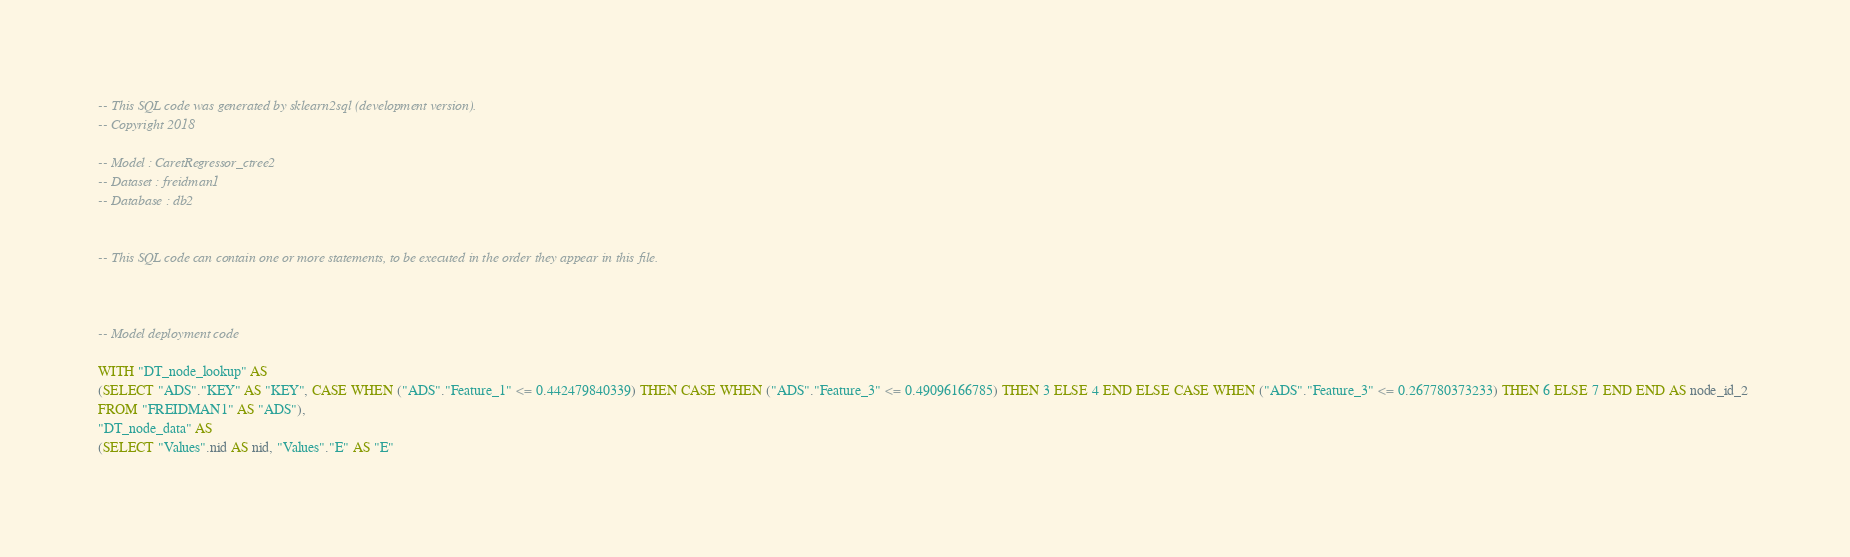Convert code to text. <code><loc_0><loc_0><loc_500><loc_500><_SQL_>-- This SQL code was generated by sklearn2sql (development version).
-- Copyright 2018

-- Model : CaretRegressor_ctree2
-- Dataset : freidman1
-- Database : db2


-- This SQL code can contain one or more statements, to be executed in the order they appear in this file.



-- Model deployment code

WITH "DT_node_lookup" AS 
(SELECT "ADS"."KEY" AS "KEY", CASE WHEN ("ADS"."Feature_1" <= 0.442479840339) THEN CASE WHEN ("ADS"."Feature_3" <= 0.49096166785) THEN 3 ELSE 4 END ELSE CASE WHEN ("ADS"."Feature_3" <= 0.267780373233) THEN 6 ELSE 7 END END AS node_id_2 
FROM "FREIDMAN1" AS "ADS"), 
"DT_node_data" AS 
(SELECT "Values".nid AS nid, "Values"."E" AS "E" </code> 